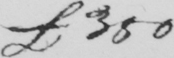What does this handwritten line say? £350 